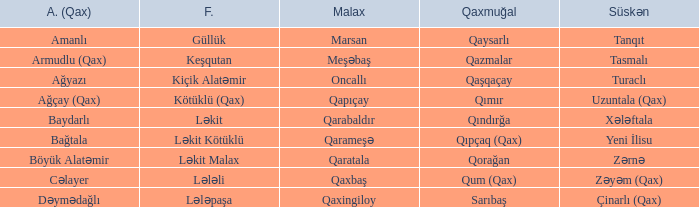What is the Süskən village with a Malax village meşəbaş? Tasmalı. 